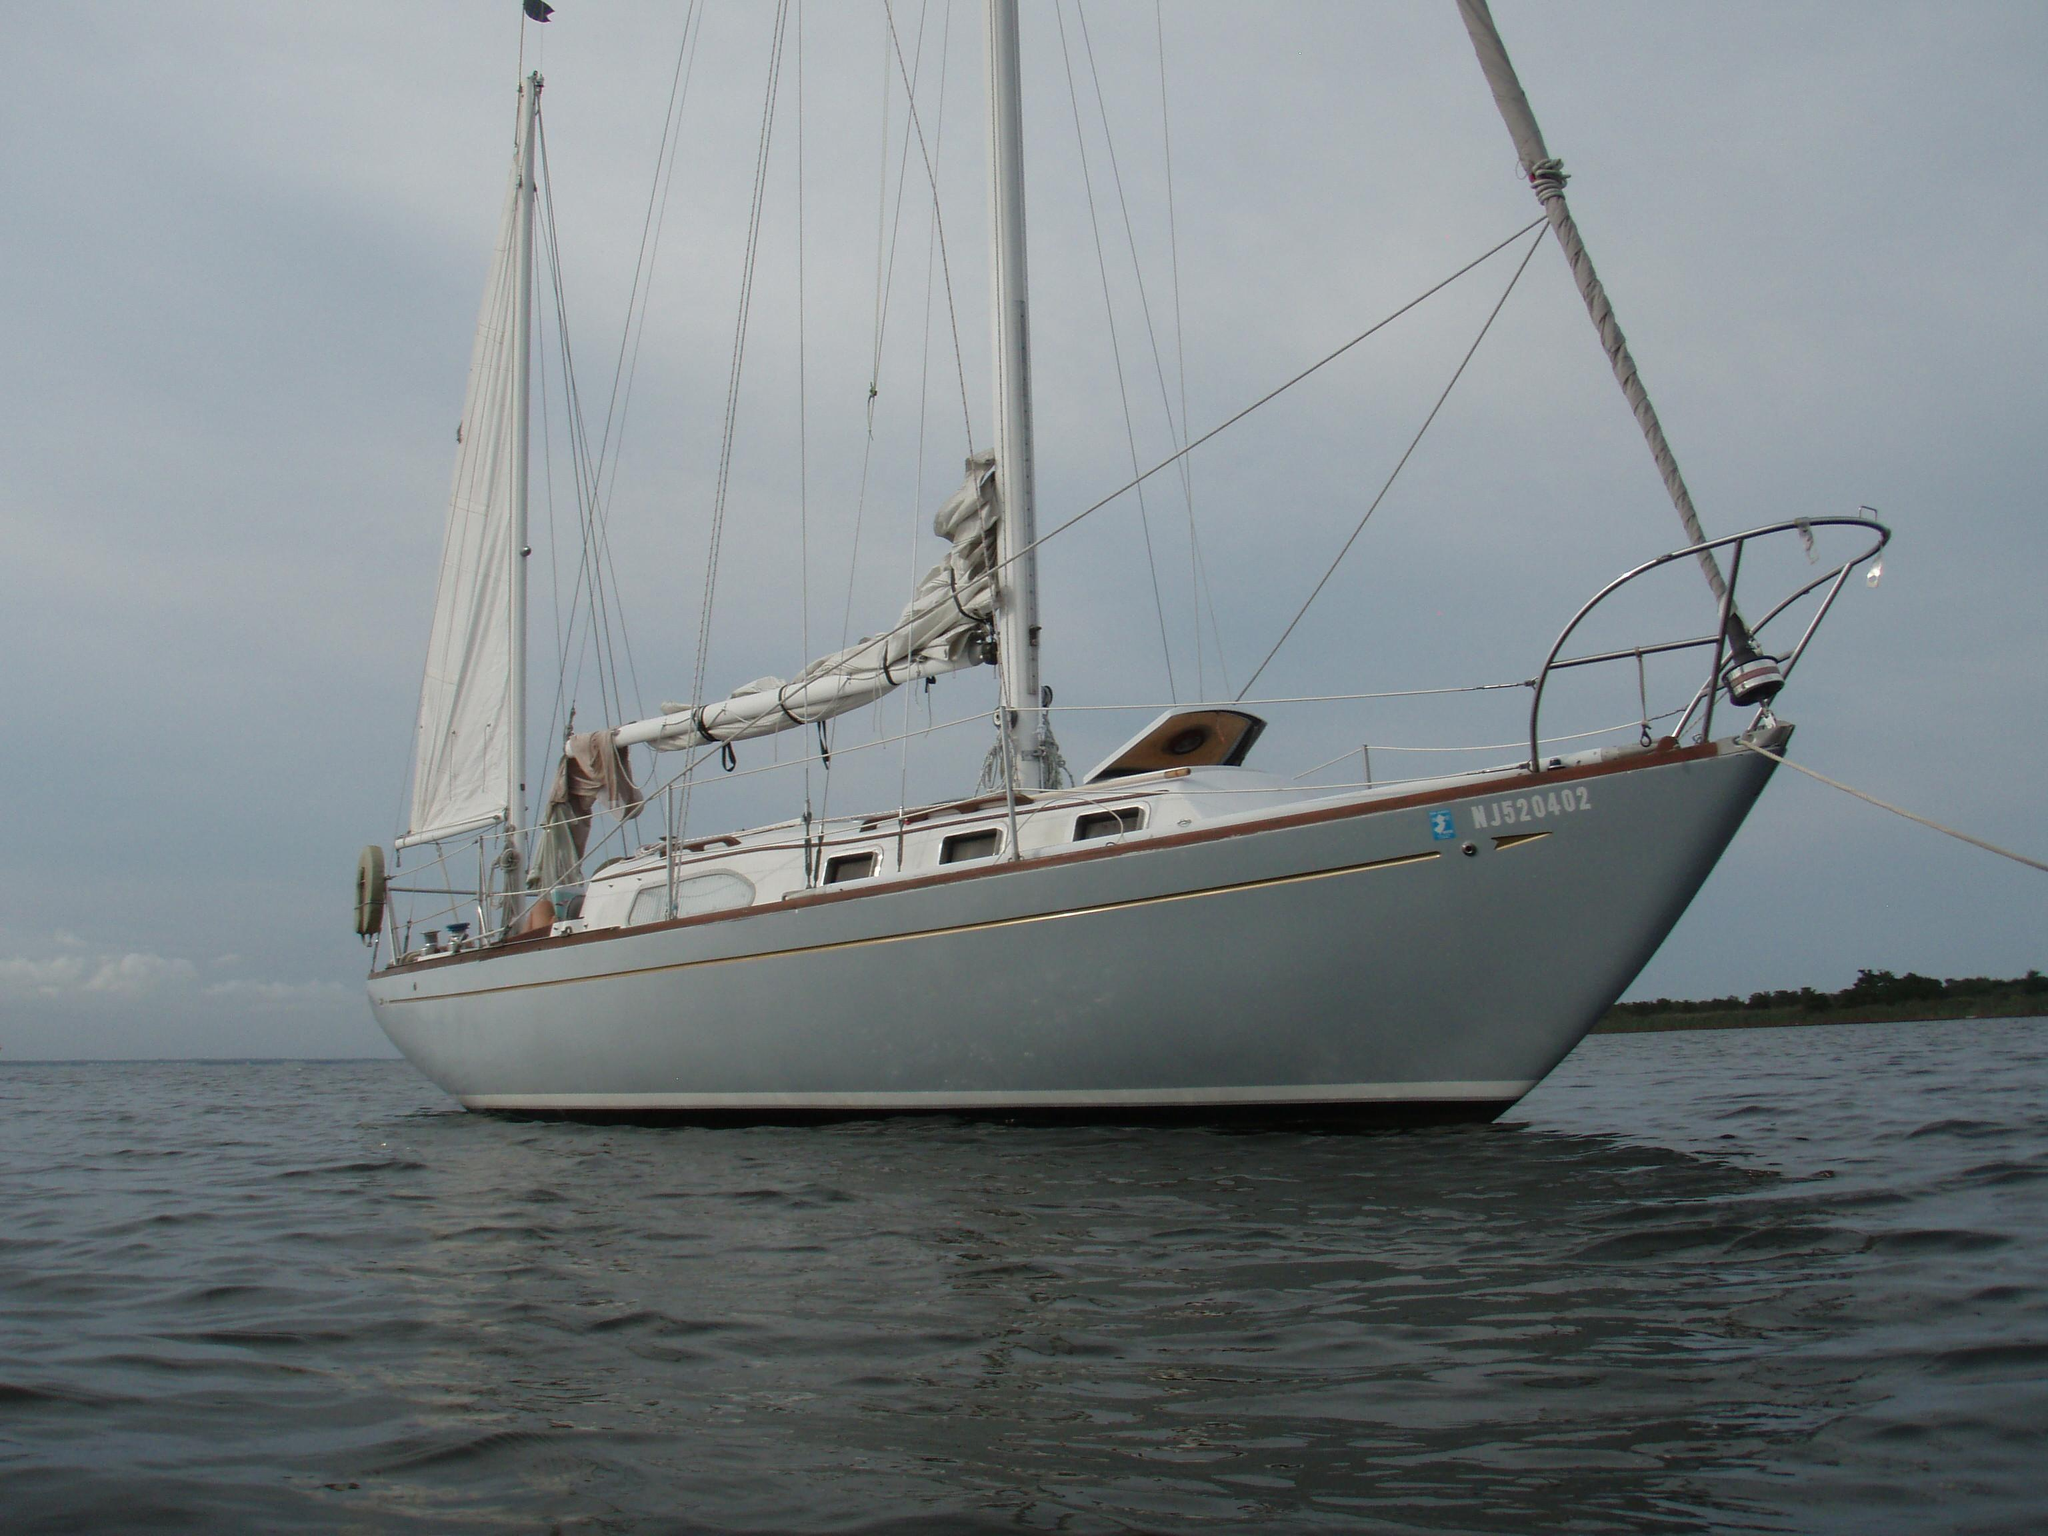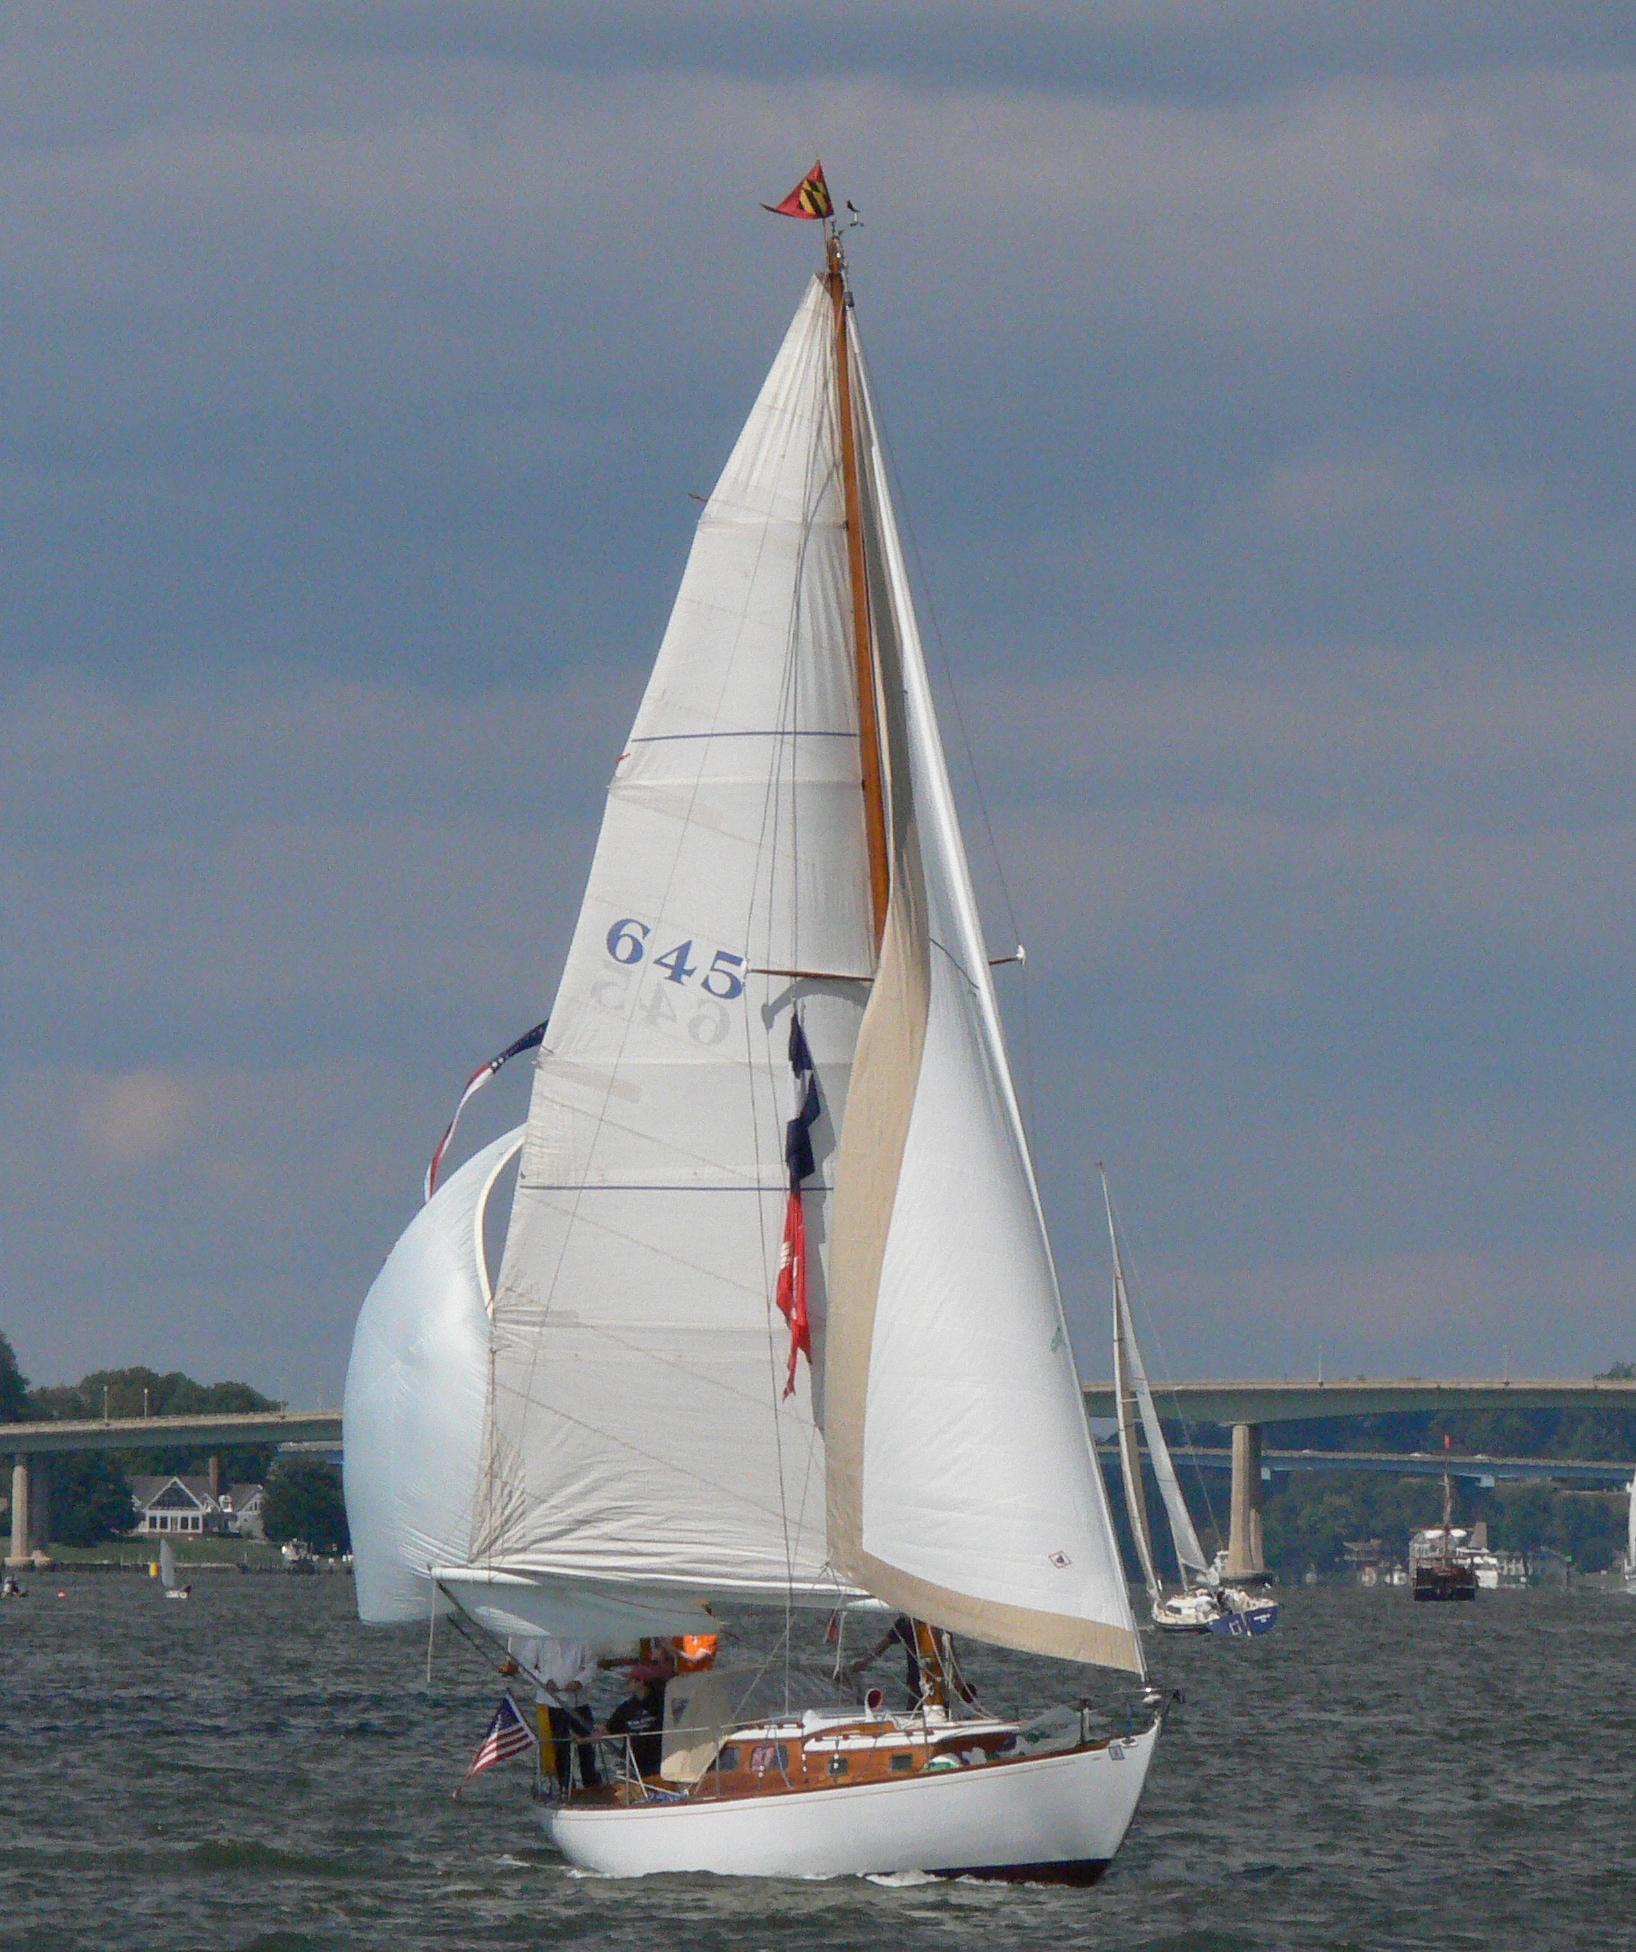The first image is the image on the left, the second image is the image on the right. Considering the images on both sides, is "The left and right image contains the same sailboat facing opposite directions." valid? Answer yes or no. Yes. The first image is the image on the left, the second image is the image on the right. For the images shown, is this caption "The left image shows a boat with a dark exterior, furled sails and a flag at one end." true? Answer yes or no. No. 